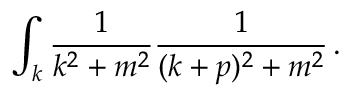Convert formula to latex. <formula><loc_0><loc_0><loc_500><loc_500>\int _ { k } { \frac { 1 } { k ^ { 2 } + m ^ { 2 } } } { \frac { 1 } { ( k + p ) ^ { 2 } + m ^ { 2 } } } \, .</formula> 